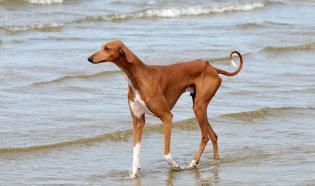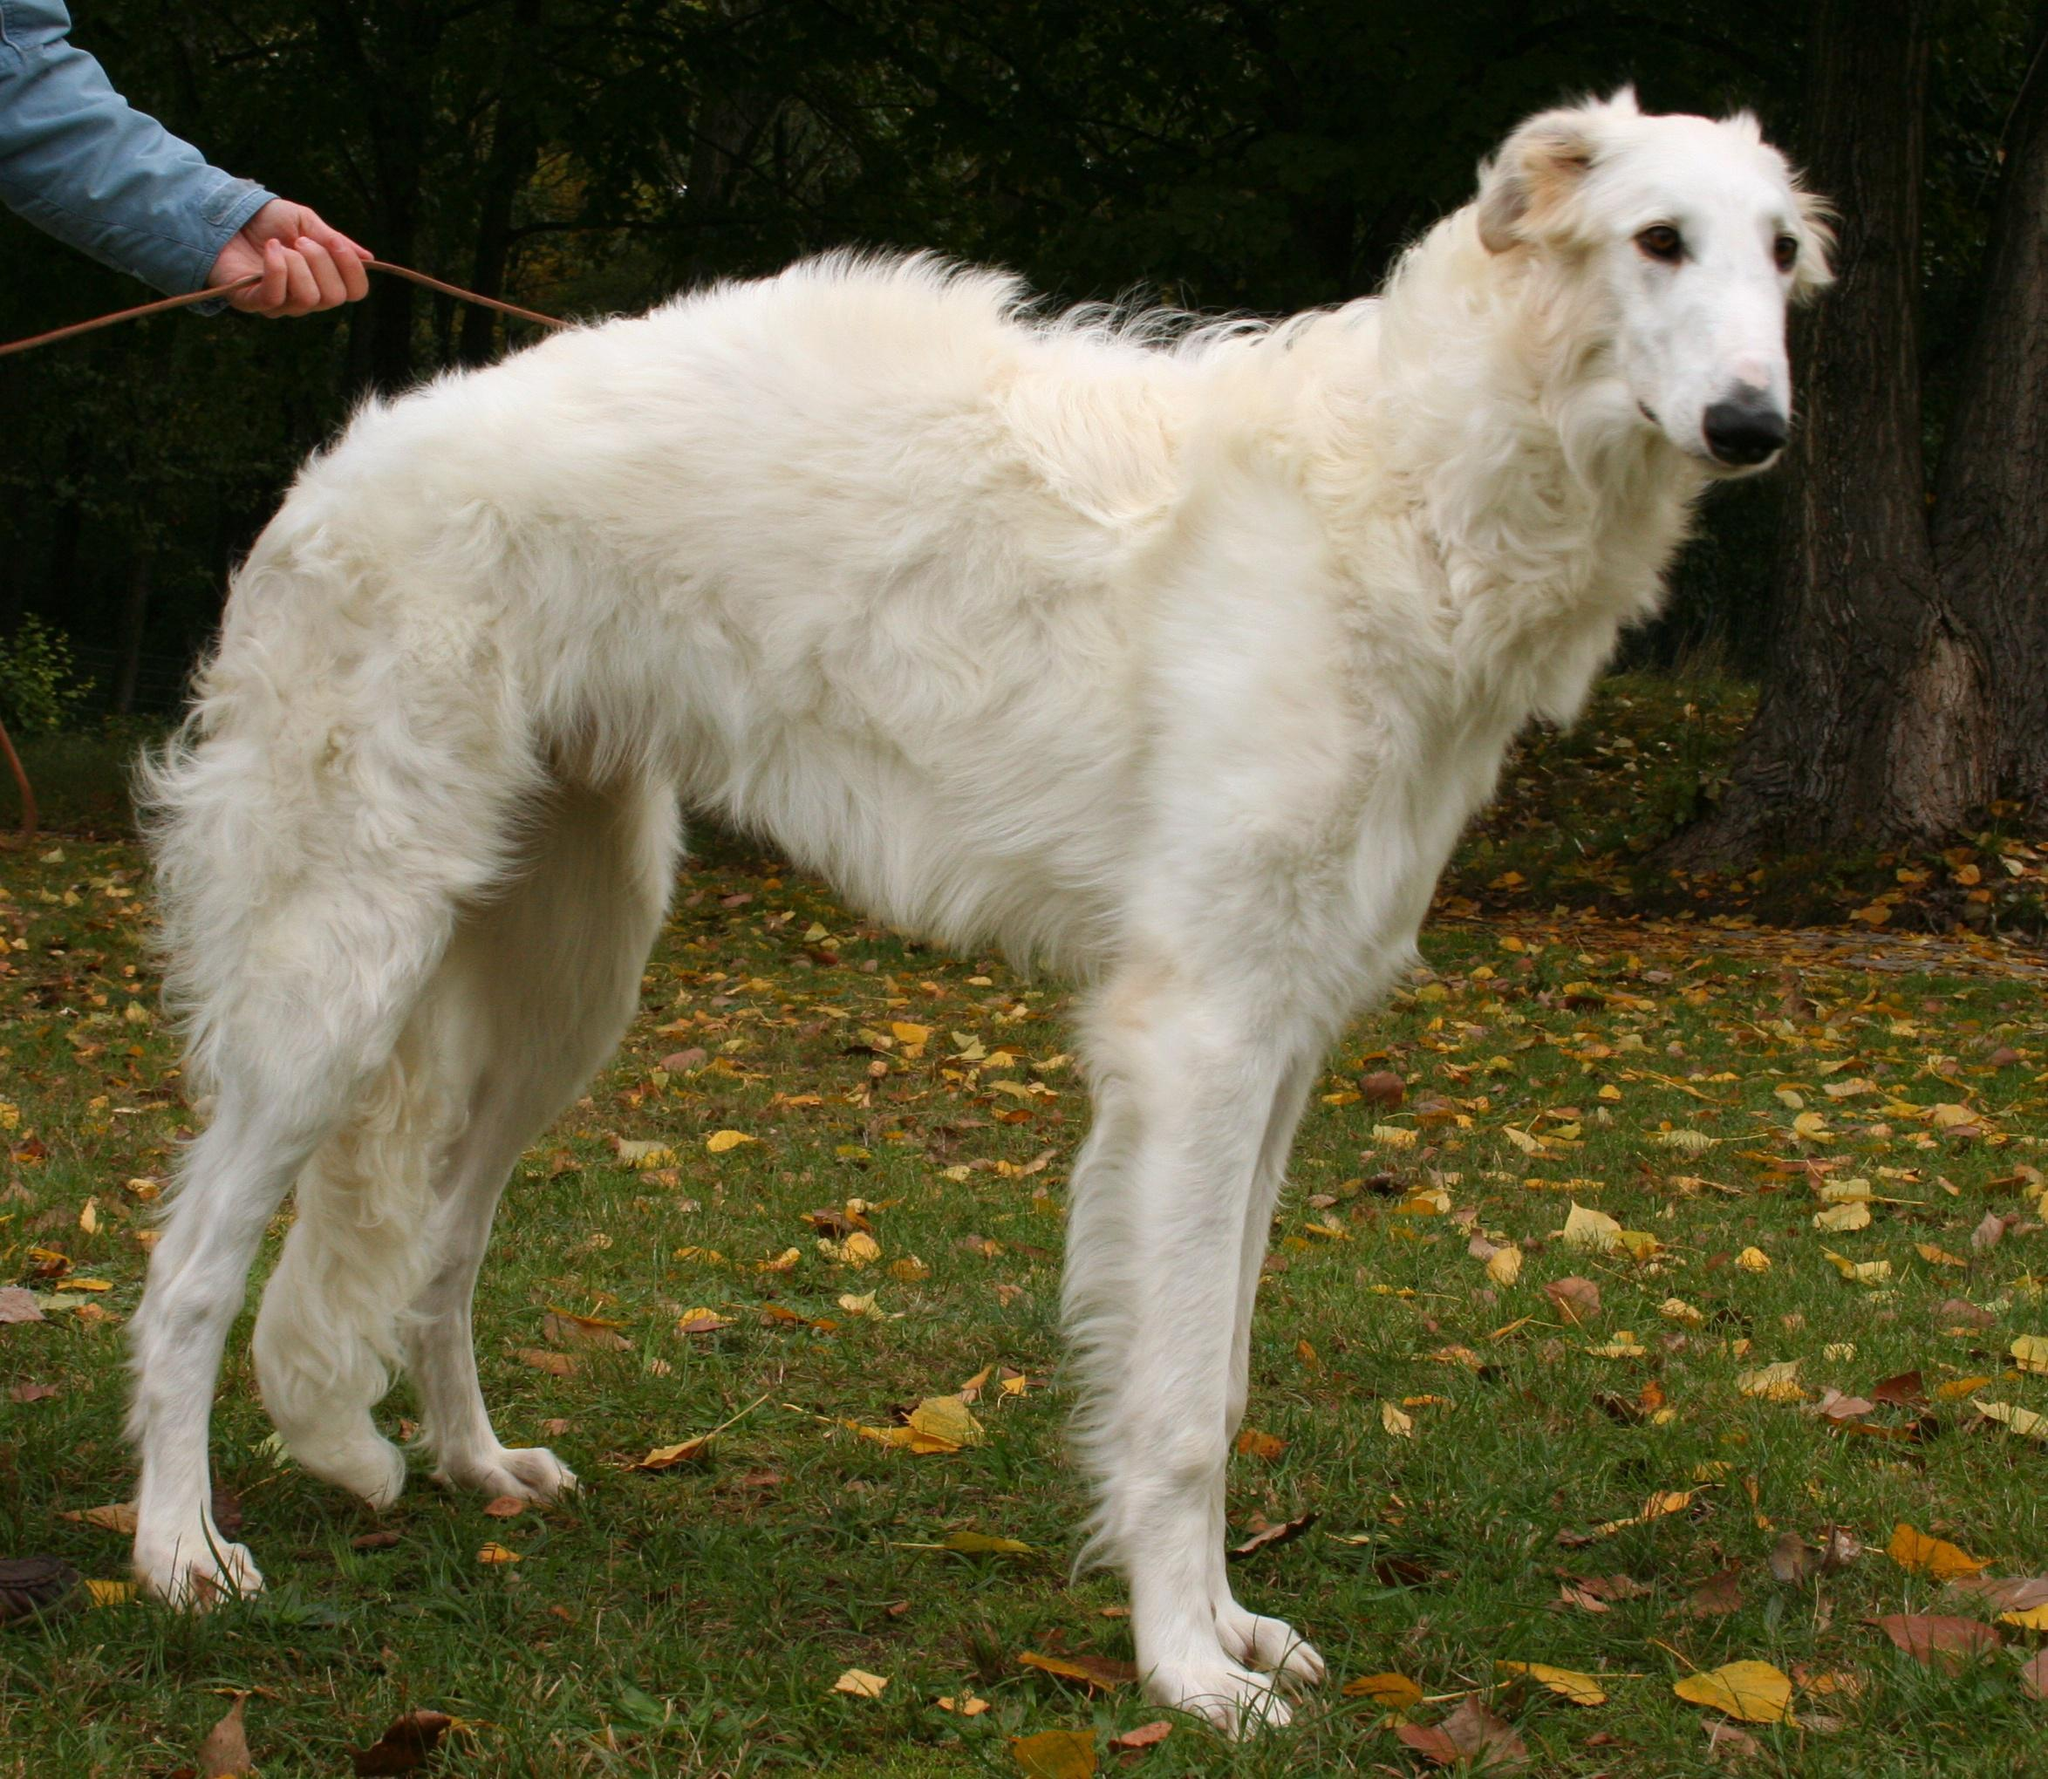The first image is the image on the left, the second image is the image on the right. For the images shown, is this caption "An image contains exactly two dogs." true? Answer yes or no. No. The first image is the image on the left, the second image is the image on the right. Considering the images on both sides, is "Each image contains exactly one hound, and the hound on the right is white and stands with its body turned rightward, while the dog on the left has orange-and-white fur." valid? Answer yes or no. Yes. 